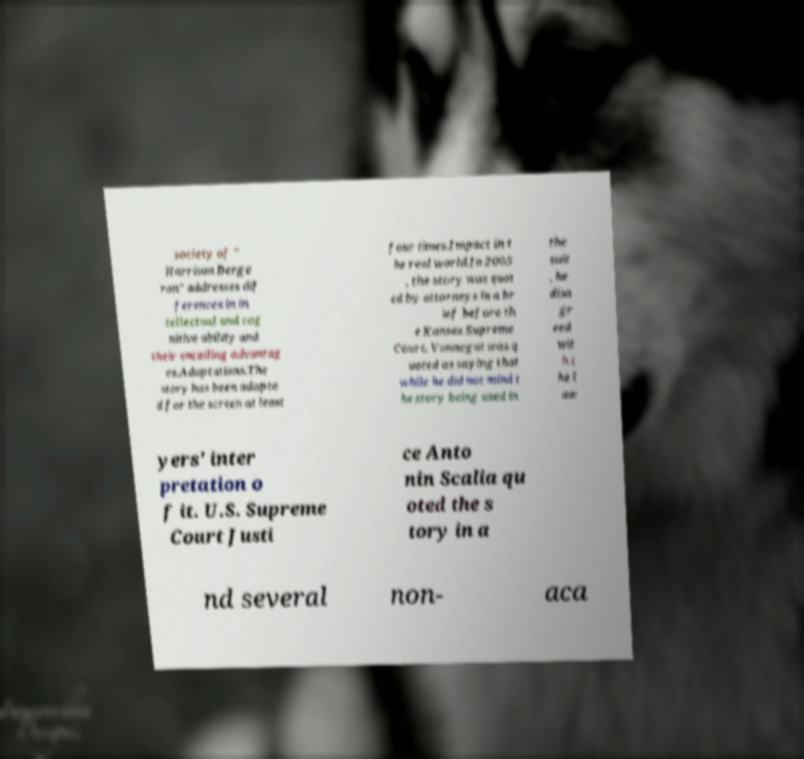Could you extract and type out the text from this image? society of " Harrison Berge ron" addresses dif ferences in in tellectual and cog nitive ability and their entailing advantag es.Adaptations.The story has been adapte d for the screen at least four times.Impact in t he real world.In 2005 , the story was quot ed by attorneys in a br ief before th e Kansas Supreme Court. Vonnegut was q uoted as saying that while he did not mind t he story being used in the suit , he disa gr eed wit h t he l aw yers' inter pretation o f it. U.S. Supreme Court Justi ce Anto nin Scalia qu oted the s tory in a nd several non- aca 